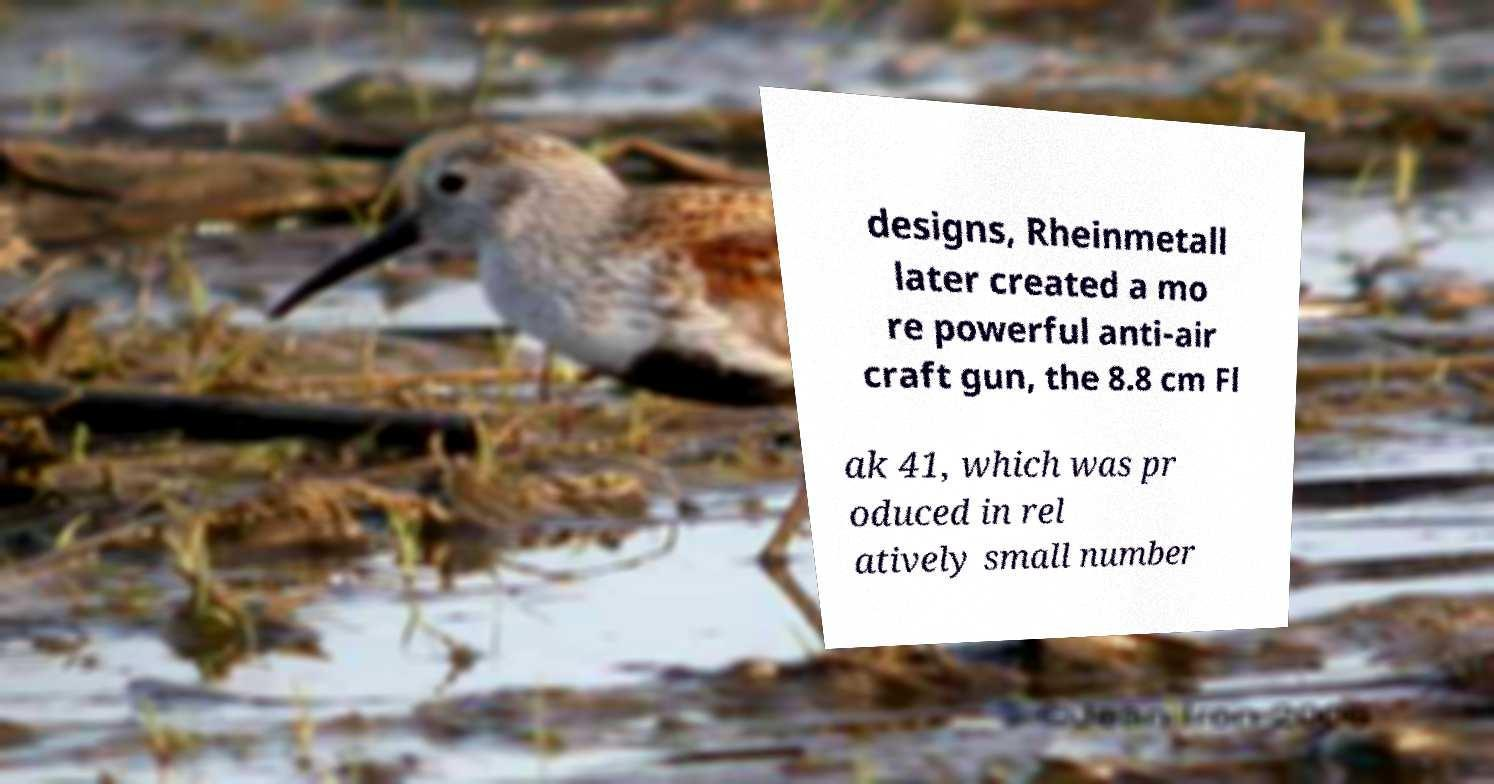Can you read and provide the text displayed in the image?This photo seems to have some interesting text. Can you extract and type it out for me? designs, Rheinmetall later created a mo re powerful anti-air craft gun, the 8.8 cm Fl ak 41, which was pr oduced in rel atively small number 